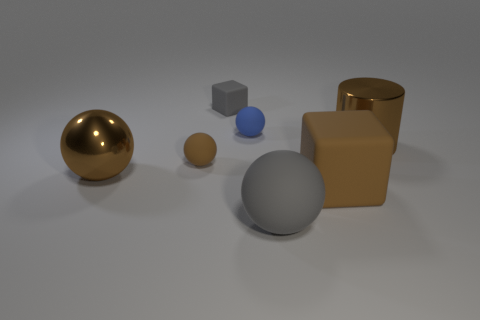Add 3 gray matte things. How many objects exist? 10 Subtract all blocks. How many objects are left? 5 Subtract 0 green balls. How many objects are left? 7 Subtract all rubber balls. Subtract all tiny rubber balls. How many objects are left? 2 Add 3 tiny brown rubber things. How many tiny brown rubber things are left? 4 Add 6 small rubber blocks. How many small rubber blocks exist? 7 